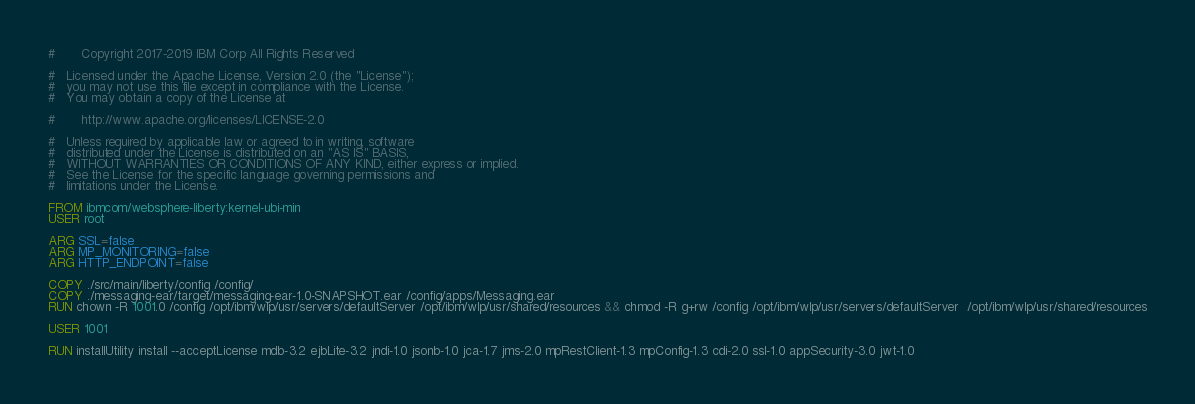<code> <loc_0><loc_0><loc_500><loc_500><_Dockerfile_>#       Copyright 2017-2019 IBM Corp All Rights Reserved

#   Licensed under the Apache License, Version 2.0 (the "License");
#   you may not use this file except in compliance with the License.
#   You may obtain a copy of the License at

#       http://www.apache.org/licenses/LICENSE-2.0

#   Unless required by applicable law or agreed to in writing, software
#   distributed under the License is distributed on an "AS IS" BASIS,
#   WITHOUT WARRANTIES OR CONDITIONS OF ANY KIND, either express or implied.
#   See the License for the specific language governing permissions and
#   limitations under the License.

FROM ibmcom/websphere-liberty:kernel-ubi-min
USER root

ARG SSL=false
ARG MP_MONITORING=false
ARG HTTP_ENDPOINT=false

COPY ./src/main/liberty/config /config/
COPY ./messaging-ear/target/messaging-ear-1.0-SNAPSHOT.ear /config/apps/Messaging.ear
RUN chown -R 1001.0 /config /opt/ibm/wlp/usr/servers/defaultServer /opt/ibm/wlp/usr/shared/resources && chmod -R g+rw /config /opt/ibm/wlp/usr/servers/defaultServer  /opt/ibm/wlp/usr/shared/resources

USER 1001

RUN installUtility install --acceptLicense mdb-3.2 ejbLite-3.2 jndi-1.0 jsonb-1.0 jca-1.7 jms-2.0 mpRestClient-1.3 mpConfig-1.3 cdi-2.0 ssl-1.0 appSecurity-3.0 jwt-1.0
</code> 